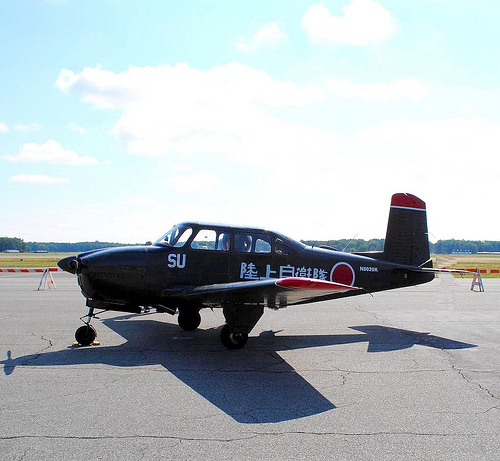Please provide the bounding box coordinate of the region this sentence describes: the nose of the plane. The bounding box coordinates encompassing the nose of the plane are [0.12, 0.55, 0.16, 0.58], a crucial part that houses avionic instruments. 